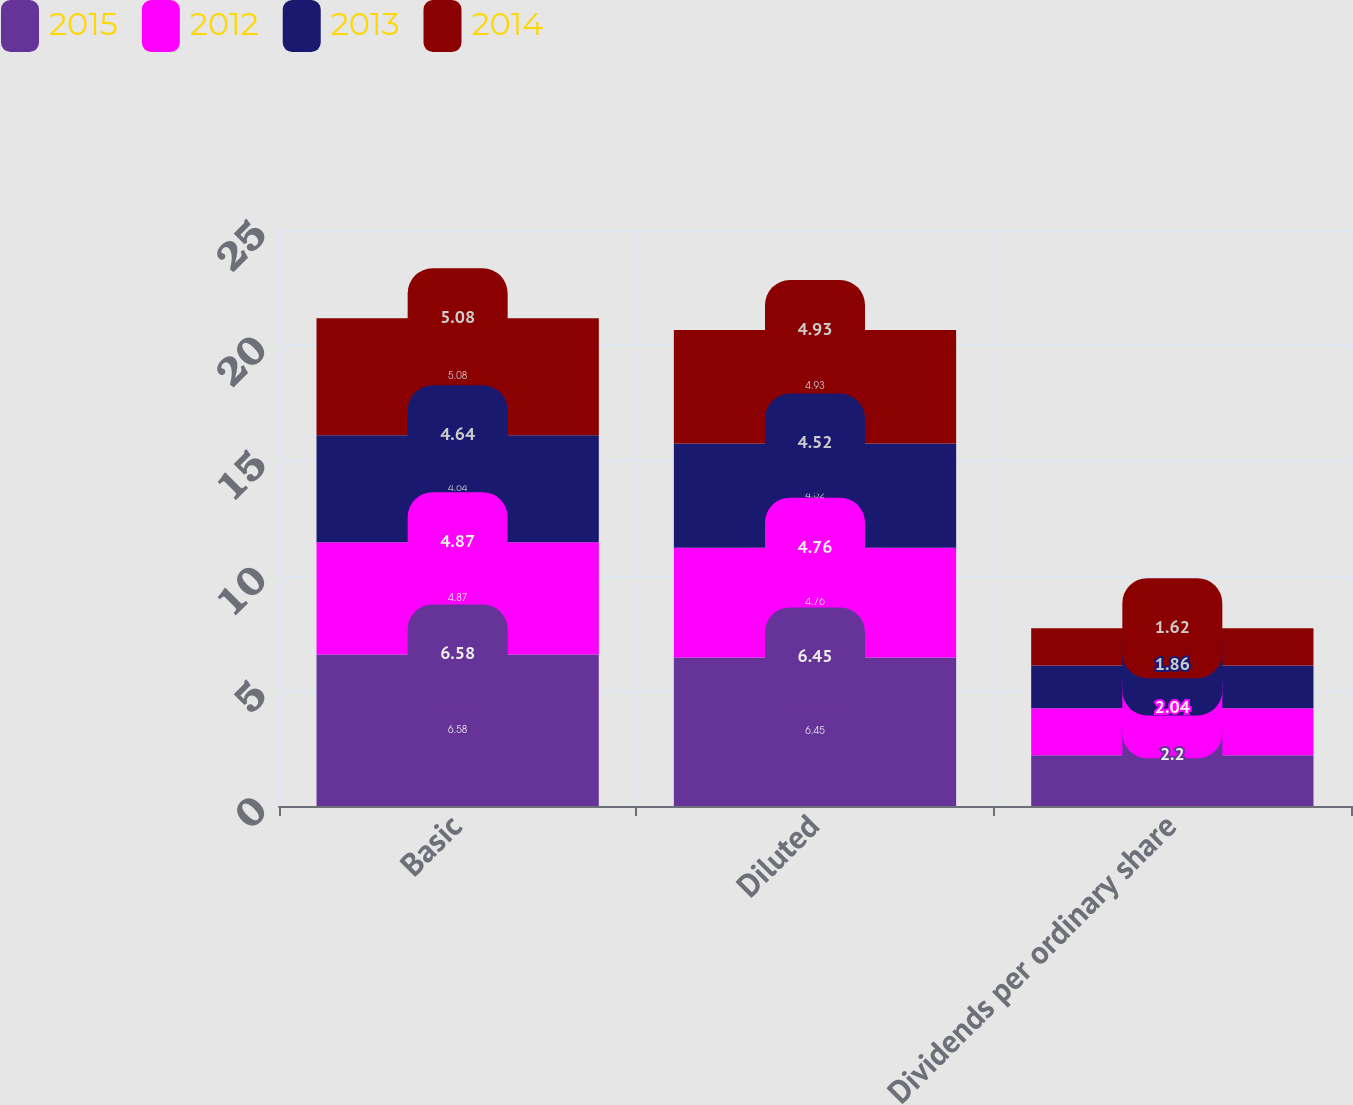Convert chart to OTSL. <chart><loc_0><loc_0><loc_500><loc_500><stacked_bar_chart><ecel><fcel>Basic<fcel>Diluted<fcel>Dividends per ordinary share<nl><fcel>2015<fcel>6.58<fcel>6.45<fcel>2.2<nl><fcel>2012<fcel>4.87<fcel>4.76<fcel>2.04<nl><fcel>2013<fcel>4.64<fcel>4.52<fcel>1.86<nl><fcel>2014<fcel>5.08<fcel>4.93<fcel>1.62<nl></chart> 